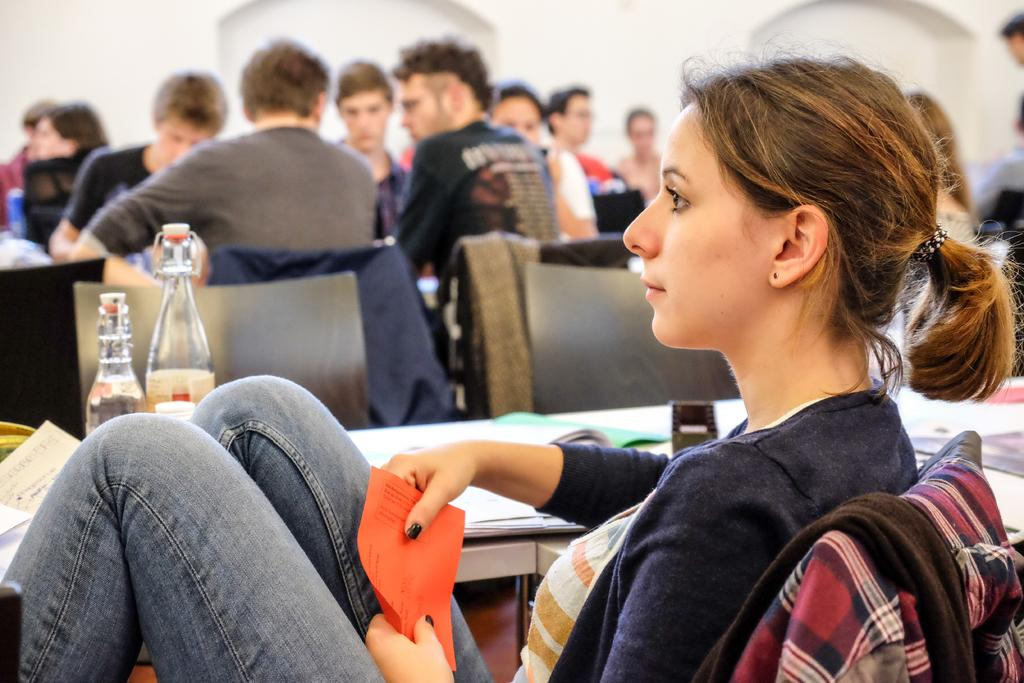How many people are in the image? There are people in the image, but the exact number is not specified. What type of furniture is in the image? There are chairs in the image. What type of clothing is in the image? There are jackets in the image. What is on the table in the image? Papers and water bottles are on the table in the image. What is visible on the wall in the image? The wall is visible in the image, but no specific details are provided. What type of soap is on the table in the image? There is no soap present on the table in the image. How many people are wearing trousers in the image? The facts do not specify the type of clothing the people are wearing, so it is impossible to determine how many are wearing trousers. 